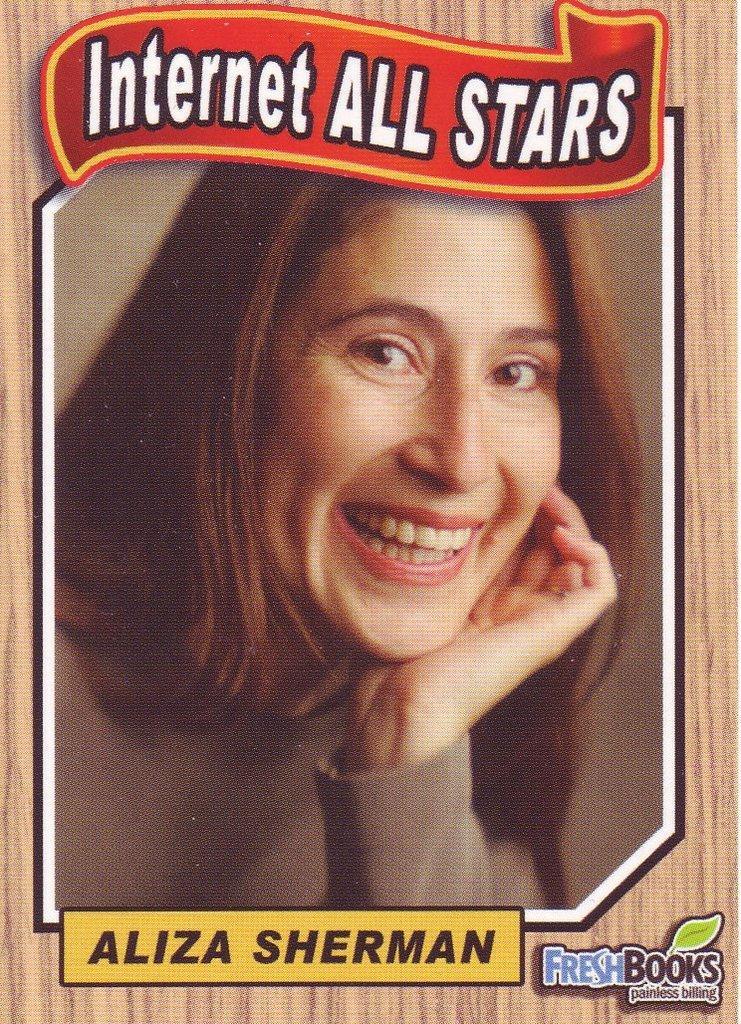Could you give a brief overview of what you see in this image? In this picture I can see a poster in front and in the poster I can see a woman and I see that she is smiling. I can also see that something is written on the top and bottom sides of this picture. 